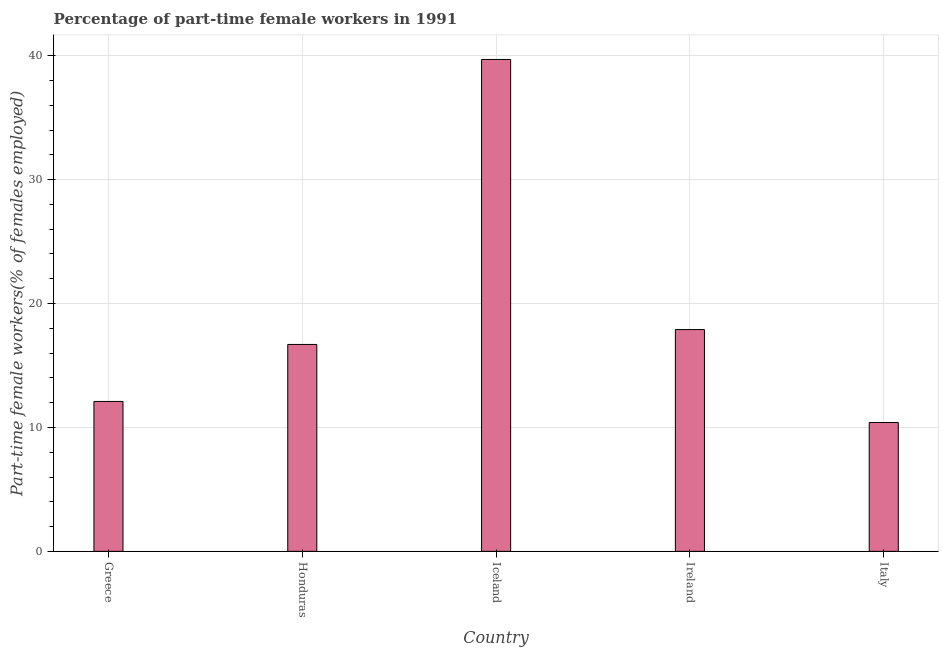What is the title of the graph?
Make the answer very short. Percentage of part-time female workers in 1991. What is the label or title of the X-axis?
Your answer should be compact. Country. What is the label or title of the Y-axis?
Your answer should be very brief. Part-time female workers(% of females employed). What is the percentage of part-time female workers in Greece?
Keep it short and to the point. 12.1. Across all countries, what is the maximum percentage of part-time female workers?
Your answer should be compact. 39.7. Across all countries, what is the minimum percentage of part-time female workers?
Your response must be concise. 10.4. What is the sum of the percentage of part-time female workers?
Your answer should be compact. 96.8. What is the average percentage of part-time female workers per country?
Your answer should be compact. 19.36. What is the median percentage of part-time female workers?
Your answer should be very brief. 16.7. In how many countries, is the percentage of part-time female workers greater than 26 %?
Keep it short and to the point. 1. What is the ratio of the percentage of part-time female workers in Honduras to that in Italy?
Your answer should be compact. 1.61. Is the difference between the percentage of part-time female workers in Iceland and Ireland greater than the difference between any two countries?
Your answer should be very brief. No. What is the difference between the highest and the second highest percentage of part-time female workers?
Your response must be concise. 21.8. What is the difference between the highest and the lowest percentage of part-time female workers?
Ensure brevity in your answer.  29.3. In how many countries, is the percentage of part-time female workers greater than the average percentage of part-time female workers taken over all countries?
Provide a short and direct response. 1. How many bars are there?
Your answer should be compact. 5. Are all the bars in the graph horizontal?
Ensure brevity in your answer.  No. What is the Part-time female workers(% of females employed) in Greece?
Your answer should be very brief. 12.1. What is the Part-time female workers(% of females employed) of Honduras?
Ensure brevity in your answer.  16.7. What is the Part-time female workers(% of females employed) in Iceland?
Provide a succinct answer. 39.7. What is the Part-time female workers(% of females employed) of Ireland?
Provide a succinct answer. 17.9. What is the Part-time female workers(% of females employed) in Italy?
Keep it short and to the point. 10.4. What is the difference between the Part-time female workers(% of females employed) in Greece and Iceland?
Give a very brief answer. -27.6. What is the difference between the Part-time female workers(% of females employed) in Greece and Ireland?
Give a very brief answer. -5.8. What is the difference between the Part-time female workers(% of females employed) in Greece and Italy?
Make the answer very short. 1.7. What is the difference between the Part-time female workers(% of females employed) in Iceland and Ireland?
Make the answer very short. 21.8. What is the difference between the Part-time female workers(% of females employed) in Iceland and Italy?
Offer a terse response. 29.3. What is the ratio of the Part-time female workers(% of females employed) in Greece to that in Honduras?
Offer a very short reply. 0.72. What is the ratio of the Part-time female workers(% of females employed) in Greece to that in Iceland?
Provide a short and direct response. 0.3. What is the ratio of the Part-time female workers(% of females employed) in Greece to that in Ireland?
Provide a short and direct response. 0.68. What is the ratio of the Part-time female workers(% of females employed) in Greece to that in Italy?
Provide a succinct answer. 1.16. What is the ratio of the Part-time female workers(% of females employed) in Honduras to that in Iceland?
Your answer should be compact. 0.42. What is the ratio of the Part-time female workers(% of females employed) in Honduras to that in Ireland?
Keep it short and to the point. 0.93. What is the ratio of the Part-time female workers(% of females employed) in Honduras to that in Italy?
Your answer should be compact. 1.61. What is the ratio of the Part-time female workers(% of females employed) in Iceland to that in Ireland?
Your answer should be very brief. 2.22. What is the ratio of the Part-time female workers(% of females employed) in Iceland to that in Italy?
Your response must be concise. 3.82. What is the ratio of the Part-time female workers(% of females employed) in Ireland to that in Italy?
Provide a short and direct response. 1.72. 